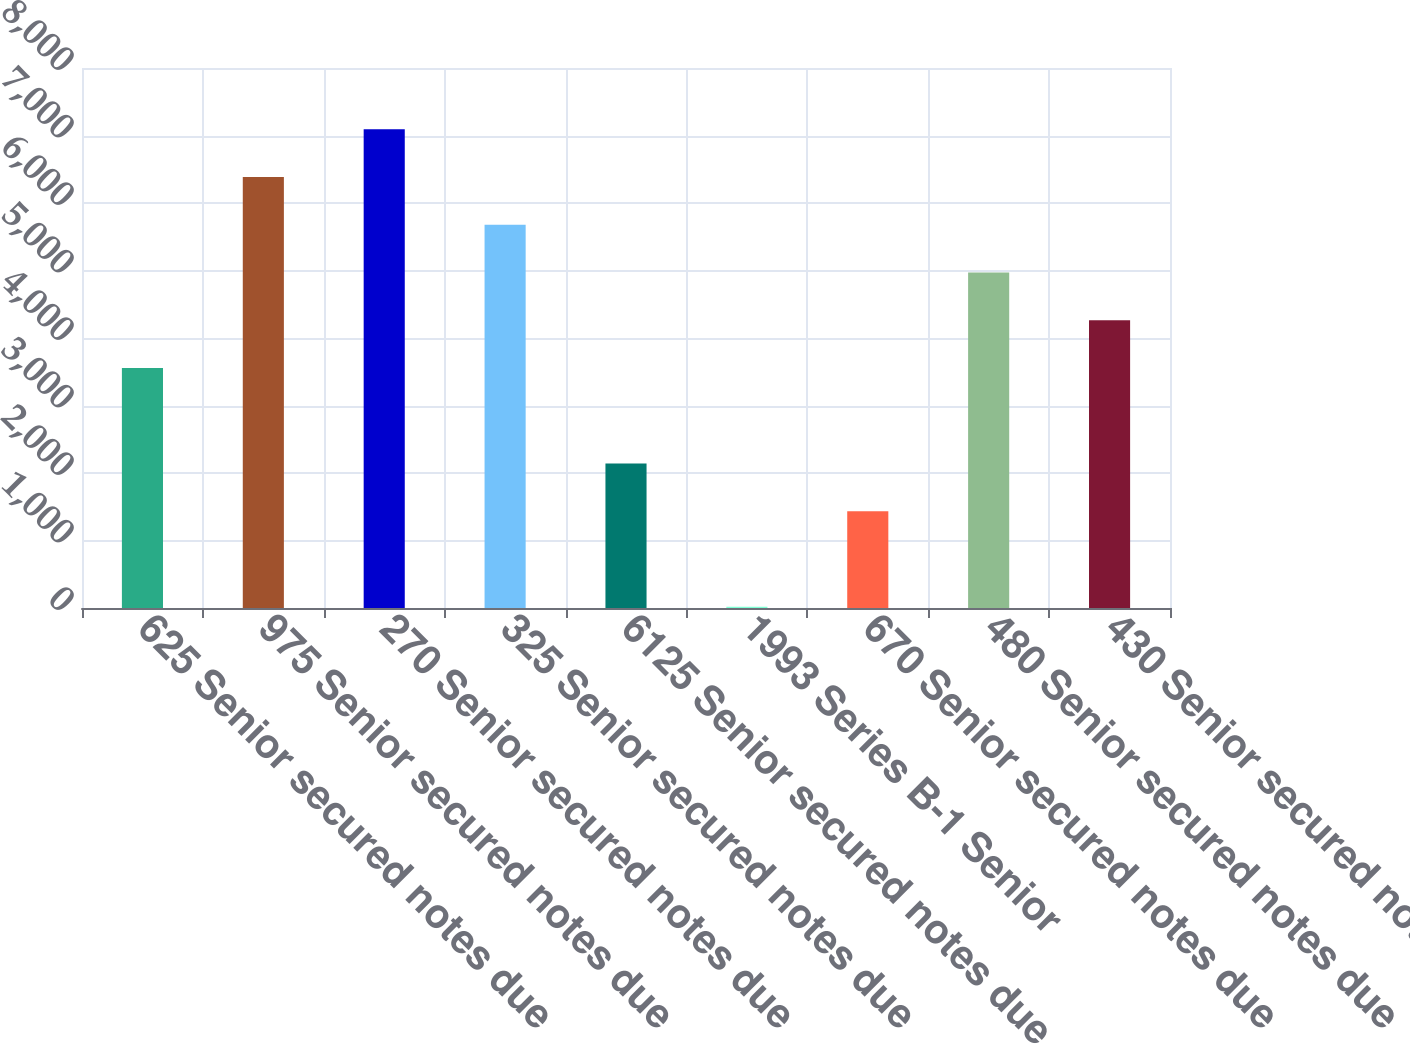<chart> <loc_0><loc_0><loc_500><loc_500><bar_chart><fcel>625 Senior secured notes due<fcel>975 Senior secured notes due<fcel>270 Senior secured notes due<fcel>325 Senior secured notes due<fcel>6125 Senior secured notes due<fcel>1993 Series B-1 Senior<fcel>670 Senior secured notes due<fcel>480 Senior secured notes due<fcel>430 Senior secured notes due<nl><fcel>3555.5<fcel>6386.3<fcel>7094<fcel>5678.6<fcel>2140.1<fcel>17<fcel>1432.4<fcel>4970.9<fcel>4263.2<nl></chart> 